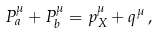Convert formula to latex. <formula><loc_0><loc_0><loc_500><loc_500>P _ { a } ^ { \mu } + P _ { b } ^ { \mu } = p _ { X } ^ { \mu } + q ^ { \mu } \, ,</formula> 